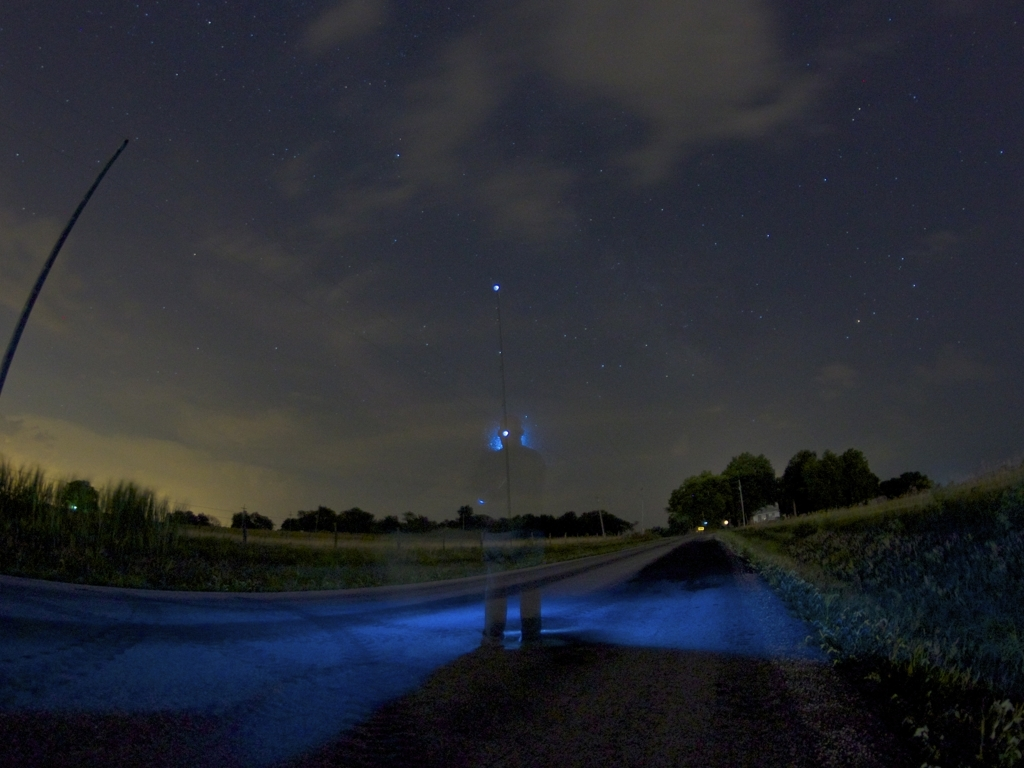What time of day do you think this photo was taken and why? The photo appears to have been taken at night, given the visible stars and the dark sky. The absence of direct light sources except for the small, concentrated lights possibly indicates the photo was shot in a rural or less urbanized area shortly after sunset or during the early night hours. What might be the blue hue on the ground? The blue hue could be from artificial lighting, such as a flashlight or a phone's light, aimed at the ground during the long-exposure. It may have been used to either illuminate the path or add an artistic touch to the picture by the photographer. 